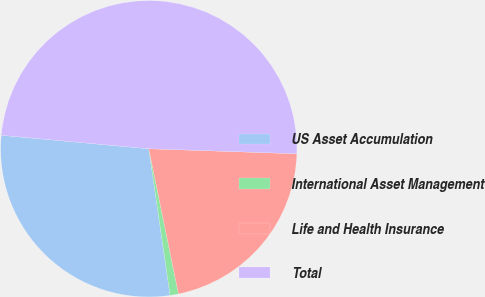Convert chart to OTSL. <chart><loc_0><loc_0><loc_500><loc_500><pie_chart><fcel>US Asset Accumulation<fcel>International Asset Management<fcel>Life and Health Insurance<fcel>Total<nl><fcel>28.75%<fcel>0.91%<fcel>21.25%<fcel>49.09%<nl></chart> 